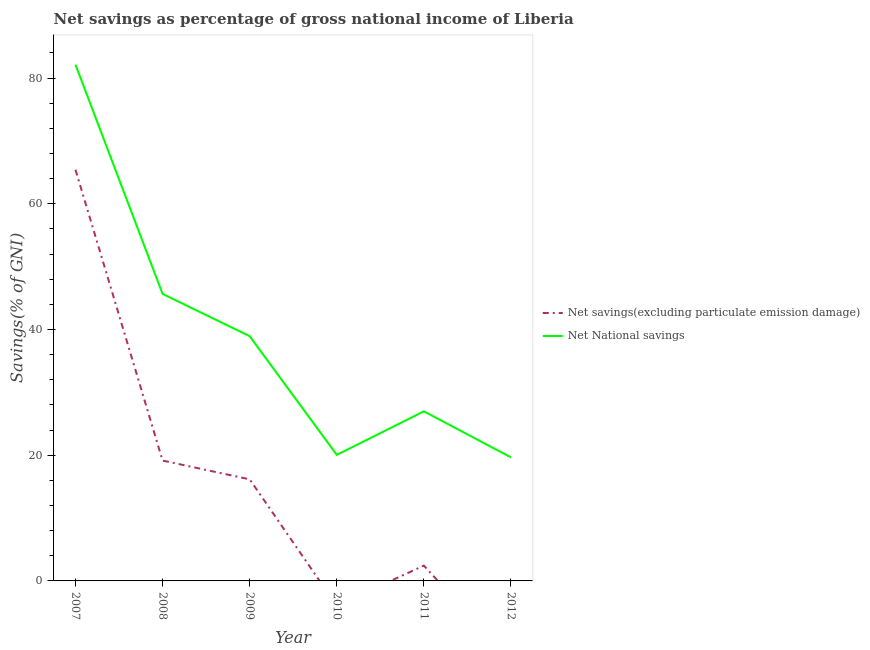Does the line corresponding to net national savings intersect with the line corresponding to net savings(excluding particulate emission damage)?
Ensure brevity in your answer.  No. Is the number of lines equal to the number of legend labels?
Offer a terse response. No. What is the net national savings in 2009?
Offer a very short reply. 38.93. Across all years, what is the maximum net national savings?
Ensure brevity in your answer.  82.12. In which year was the net national savings maximum?
Offer a terse response. 2007. What is the total net national savings in the graph?
Your response must be concise. 233.39. What is the difference between the net national savings in 2007 and that in 2011?
Provide a succinct answer. 55.14. What is the difference between the net savings(excluding particulate emission damage) in 2011 and the net national savings in 2008?
Your response must be concise. -43.22. What is the average net national savings per year?
Make the answer very short. 38.9. In the year 2008, what is the difference between the net savings(excluding particulate emission damage) and net national savings?
Provide a succinct answer. -26.51. In how many years, is the net savings(excluding particulate emission damage) greater than 36 %?
Provide a succinct answer. 1. What is the ratio of the net savings(excluding particulate emission damage) in 2008 to that in 2011?
Keep it short and to the point. 7.85. Is the net national savings in 2010 less than that in 2012?
Offer a very short reply. No. What is the difference between the highest and the second highest net national savings?
Your response must be concise. 36.46. What is the difference between the highest and the lowest net savings(excluding particulate emission damage)?
Offer a very short reply. 65.41. Is the net national savings strictly greater than the net savings(excluding particulate emission damage) over the years?
Provide a short and direct response. Yes. Is the net savings(excluding particulate emission damage) strictly less than the net national savings over the years?
Your answer should be very brief. Yes. How many years are there in the graph?
Provide a short and direct response. 6. What is the difference between two consecutive major ticks on the Y-axis?
Offer a very short reply. 20. Are the values on the major ticks of Y-axis written in scientific E-notation?
Your response must be concise. No. Does the graph contain any zero values?
Ensure brevity in your answer.  Yes. Does the graph contain grids?
Offer a very short reply. No. Where does the legend appear in the graph?
Offer a terse response. Center right. How many legend labels are there?
Make the answer very short. 2. What is the title of the graph?
Offer a very short reply. Net savings as percentage of gross national income of Liberia. What is the label or title of the Y-axis?
Your answer should be very brief. Savings(% of GNI). What is the Savings(% of GNI) in Net savings(excluding particulate emission damage) in 2007?
Offer a terse response. 65.41. What is the Savings(% of GNI) of Net National savings in 2007?
Your response must be concise. 82.12. What is the Savings(% of GNI) of Net savings(excluding particulate emission damage) in 2008?
Give a very brief answer. 19.15. What is the Savings(% of GNI) of Net National savings in 2008?
Provide a short and direct response. 45.66. What is the Savings(% of GNI) of Net savings(excluding particulate emission damage) in 2009?
Provide a short and direct response. 16.16. What is the Savings(% of GNI) in Net National savings in 2009?
Make the answer very short. 38.93. What is the Savings(% of GNI) in Net National savings in 2010?
Offer a very short reply. 20.05. What is the Savings(% of GNI) in Net savings(excluding particulate emission damage) in 2011?
Give a very brief answer. 2.44. What is the Savings(% of GNI) in Net National savings in 2011?
Your response must be concise. 26.98. What is the Savings(% of GNI) of Net National savings in 2012?
Provide a short and direct response. 19.65. Across all years, what is the maximum Savings(% of GNI) in Net savings(excluding particulate emission damage)?
Offer a very short reply. 65.41. Across all years, what is the maximum Savings(% of GNI) in Net National savings?
Your answer should be very brief. 82.12. Across all years, what is the minimum Savings(% of GNI) of Net savings(excluding particulate emission damage)?
Offer a very short reply. 0. Across all years, what is the minimum Savings(% of GNI) in Net National savings?
Provide a short and direct response. 19.65. What is the total Savings(% of GNI) in Net savings(excluding particulate emission damage) in the graph?
Offer a terse response. 103.15. What is the total Savings(% of GNI) of Net National savings in the graph?
Offer a very short reply. 233.39. What is the difference between the Savings(% of GNI) of Net savings(excluding particulate emission damage) in 2007 and that in 2008?
Keep it short and to the point. 46.26. What is the difference between the Savings(% of GNI) in Net National savings in 2007 and that in 2008?
Ensure brevity in your answer.  36.46. What is the difference between the Savings(% of GNI) in Net savings(excluding particulate emission damage) in 2007 and that in 2009?
Offer a terse response. 49.25. What is the difference between the Savings(% of GNI) of Net National savings in 2007 and that in 2009?
Provide a succinct answer. 43.19. What is the difference between the Savings(% of GNI) of Net National savings in 2007 and that in 2010?
Offer a very short reply. 62.07. What is the difference between the Savings(% of GNI) of Net savings(excluding particulate emission damage) in 2007 and that in 2011?
Make the answer very short. 62.97. What is the difference between the Savings(% of GNI) of Net National savings in 2007 and that in 2011?
Give a very brief answer. 55.14. What is the difference between the Savings(% of GNI) in Net National savings in 2007 and that in 2012?
Your answer should be compact. 62.47. What is the difference between the Savings(% of GNI) in Net savings(excluding particulate emission damage) in 2008 and that in 2009?
Make the answer very short. 2.99. What is the difference between the Savings(% of GNI) in Net National savings in 2008 and that in 2009?
Provide a succinct answer. 6.73. What is the difference between the Savings(% of GNI) in Net National savings in 2008 and that in 2010?
Offer a terse response. 25.61. What is the difference between the Savings(% of GNI) in Net savings(excluding particulate emission damage) in 2008 and that in 2011?
Your answer should be very brief. 16.71. What is the difference between the Savings(% of GNI) of Net National savings in 2008 and that in 2011?
Offer a very short reply. 18.68. What is the difference between the Savings(% of GNI) in Net National savings in 2008 and that in 2012?
Your answer should be very brief. 26.01. What is the difference between the Savings(% of GNI) in Net National savings in 2009 and that in 2010?
Offer a terse response. 18.88. What is the difference between the Savings(% of GNI) of Net savings(excluding particulate emission damage) in 2009 and that in 2011?
Make the answer very short. 13.72. What is the difference between the Savings(% of GNI) in Net National savings in 2009 and that in 2011?
Keep it short and to the point. 11.95. What is the difference between the Savings(% of GNI) in Net National savings in 2009 and that in 2012?
Offer a very short reply. 19.28. What is the difference between the Savings(% of GNI) of Net National savings in 2010 and that in 2011?
Your answer should be very brief. -6.93. What is the difference between the Savings(% of GNI) of Net National savings in 2010 and that in 2012?
Provide a short and direct response. 0.4. What is the difference between the Savings(% of GNI) of Net National savings in 2011 and that in 2012?
Offer a terse response. 7.33. What is the difference between the Savings(% of GNI) of Net savings(excluding particulate emission damage) in 2007 and the Savings(% of GNI) of Net National savings in 2008?
Give a very brief answer. 19.75. What is the difference between the Savings(% of GNI) in Net savings(excluding particulate emission damage) in 2007 and the Savings(% of GNI) in Net National savings in 2009?
Ensure brevity in your answer.  26.48. What is the difference between the Savings(% of GNI) in Net savings(excluding particulate emission damage) in 2007 and the Savings(% of GNI) in Net National savings in 2010?
Offer a very short reply. 45.36. What is the difference between the Savings(% of GNI) in Net savings(excluding particulate emission damage) in 2007 and the Savings(% of GNI) in Net National savings in 2011?
Offer a very short reply. 38.43. What is the difference between the Savings(% of GNI) in Net savings(excluding particulate emission damage) in 2007 and the Savings(% of GNI) in Net National savings in 2012?
Make the answer very short. 45.76. What is the difference between the Savings(% of GNI) in Net savings(excluding particulate emission damage) in 2008 and the Savings(% of GNI) in Net National savings in 2009?
Give a very brief answer. -19.79. What is the difference between the Savings(% of GNI) in Net savings(excluding particulate emission damage) in 2008 and the Savings(% of GNI) in Net National savings in 2010?
Ensure brevity in your answer.  -0.9. What is the difference between the Savings(% of GNI) of Net savings(excluding particulate emission damage) in 2008 and the Savings(% of GNI) of Net National savings in 2011?
Your answer should be very brief. -7.83. What is the difference between the Savings(% of GNI) in Net savings(excluding particulate emission damage) in 2008 and the Savings(% of GNI) in Net National savings in 2012?
Ensure brevity in your answer.  -0.5. What is the difference between the Savings(% of GNI) of Net savings(excluding particulate emission damage) in 2009 and the Savings(% of GNI) of Net National savings in 2010?
Provide a short and direct response. -3.89. What is the difference between the Savings(% of GNI) of Net savings(excluding particulate emission damage) in 2009 and the Savings(% of GNI) of Net National savings in 2011?
Offer a very short reply. -10.82. What is the difference between the Savings(% of GNI) in Net savings(excluding particulate emission damage) in 2009 and the Savings(% of GNI) in Net National savings in 2012?
Ensure brevity in your answer.  -3.49. What is the difference between the Savings(% of GNI) of Net savings(excluding particulate emission damage) in 2011 and the Savings(% of GNI) of Net National savings in 2012?
Give a very brief answer. -17.21. What is the average Savings(% of GNI) of Net savings(excluding particulate emission damage) per year?
Your response must be concise. 17.19. What is the average Savings(% of GNI) of Net National savings per year?
Offer a terse response. 38.9. In the year 2007, what is the difference between the Savings(% of GNI) in Net savings(excluding particulate emission damage) and Savings(% of GNI) in Net National savings?
Give a very brief answer. -16.71. In the year 2008, what is the difference between the Savings(% of GNI) in Net savings(excluding particulate emission damage) and Savings(% of GNI) in Net National savings?
Your answer should be very brief. -26.51. In the year 2009, what is the difference between the Savings(% of GNI) of Net savings(excluding particulate emission damage) and Savings(% of GNI) of Net National savings?
Your response must be concise. -22.77. In the year 2011, what is the difference between the Savings(% of GNI) in Net savings(excluding particulate emission damage) and Savings(% of GNI) in Net National savings?
Make the answer very short. -24.54. What is the ratio of the Savings(% of GNI) in Net savings(excluding particulate emission damage) in 2007 to that in 2008?
Give a very brief answer. 3.42. What is the ratio of the Savings(% of GNI) of Net National savings in 2007 to that in 2008?
Provide a short and direct response. 1.8. What is the ratio of the Savings(% of GNI) in Net savings(excluding particulate emission damage) in 2007 to that in 2009?
Provide a short and direct response. 4.05. What is the ratio of the Savings(% of GNI) in Net National savings in 2007 to that in 2009?
Keep it short and to the point. 2.11. What is the ratio of the Savings(% of GNI) in Net National savings in 2007 to that in 2010?
Offer a very short reply. 4.1. What is the ratio of the Savings(% of GNI) of Net savings(excluding particulate emission damage) in 2007 to that in 2011?
Your answer should be very brief. 26.82. What is the ratio of the Savings(% of GNI) of Net National savings in 2007 to that in 2011?
Offer a terse response. 3.04. What is the ratio of the Savings(% of GNI) in Net National savings in 2007 to that in 2012?
Make the answer very short. 4.18. What is the ratio of the Savings(% of GNI) of Net savings(excluding particulate emission damage) in 2008 to that in 2009?
Make the answer very short. 1.18. What is the ratio of the Savings(% of GNI) in Net National savings in 2008 to that in 2009?
Your answer should be compact. 1.17. What is the ratio of the Savings(% of GNI) of Net National savings in 2008 to that in 2010?
Ensure brevity in your answer.  2.28. What is the ratio of the Savings(% of GNI) of Net savings(excluding particulate emission damage) in 2008 to that in 2011?
Your answer should be compact. 7.85. What is the ratio of the Savings(% of GNI) of Net National savings in 2008 to that in 2011?
Offer a terse response. 1.69. What is the ratio of the Savings(% of GNI) in Net National savings in 2008 to that in 2012?
Provide a succinct answer. 2.32. What is the ratio of the Savings(% of GNI) of Net National savings in 2009 to that in 2010?
Make the answer very short. 1.94. What is the ratio of the Savings(% of GNI) of Net savings(excluding particulate emission damage) in 2009 to that in 2011?
Your response must be concise. 6.63. What is the ratio of the Savings(% of GNI) of Net National savings in 2009 to that in 2011?
Provide a short and direct response. 1.44. What is the ratio of the Savings(% of GNI) of Net National savings in 2009 to that in 2012?
Ensure brevity in your answer.  1.98. What is the ratio of the Savings(% of GNI) in Net National savings in 2010 to that in 2011?
Provide a succinct answer. 0.74. What is the ratio of the Savings(% of GNI) of Net National savings in 2010 to that in 2012?
Offer a very short reply. 1.02. What is the ratio of the Savings(% of GNI) in Net National savings in 2011 to that in 2012?
Your answer should be compact. 1.37. What is the difference between the highest and the second highest Savings(% of GNI) in Net savings(excluding particulate emission damage)?
Provide a short and direct response. 46.26. What is the difference between the highest and the second highest Savings(% of GNI) of Net National savings?
Keep it short and to the point. 36.46. What is the difference between the highest and the lowest Savings(% of GNI) in Net savings(excluding particulate emission damage)?
Your response must be concise. 65.41. What is the difference between the highest and the lowest Savings(% of GNI) of Net National savings?
Offer a terse response. 62.47. 